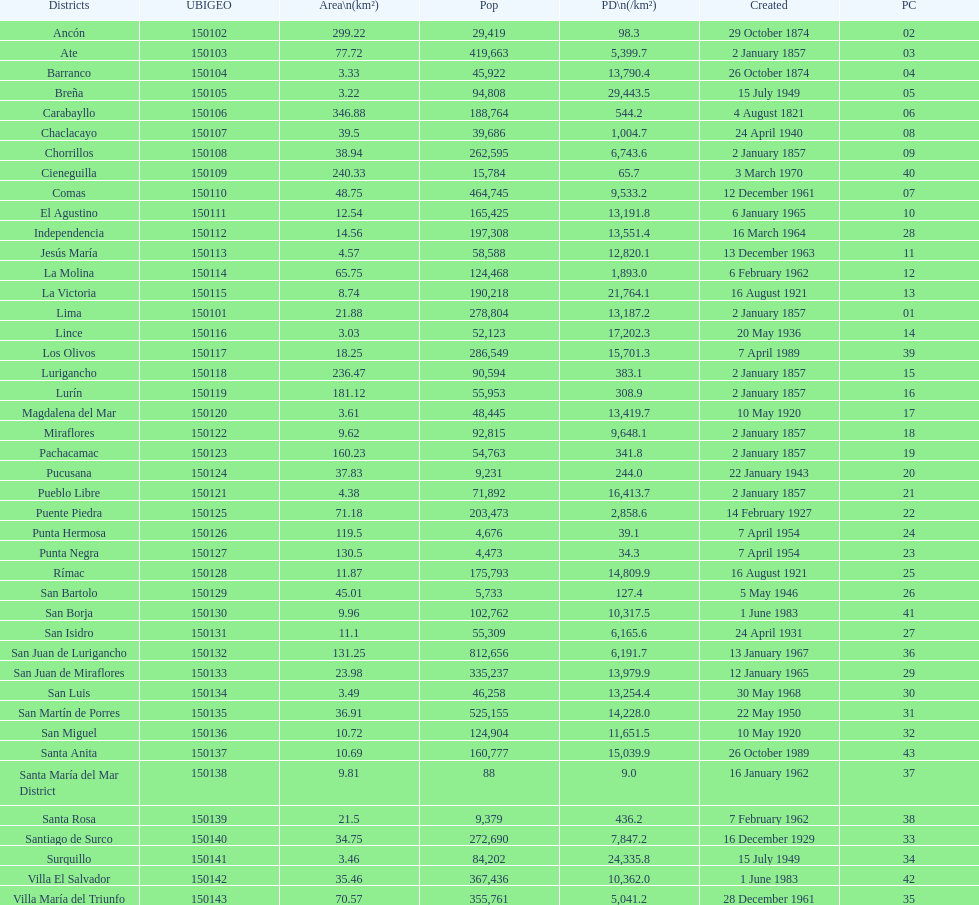What is the total number of districts created in the 1900's? 32. 